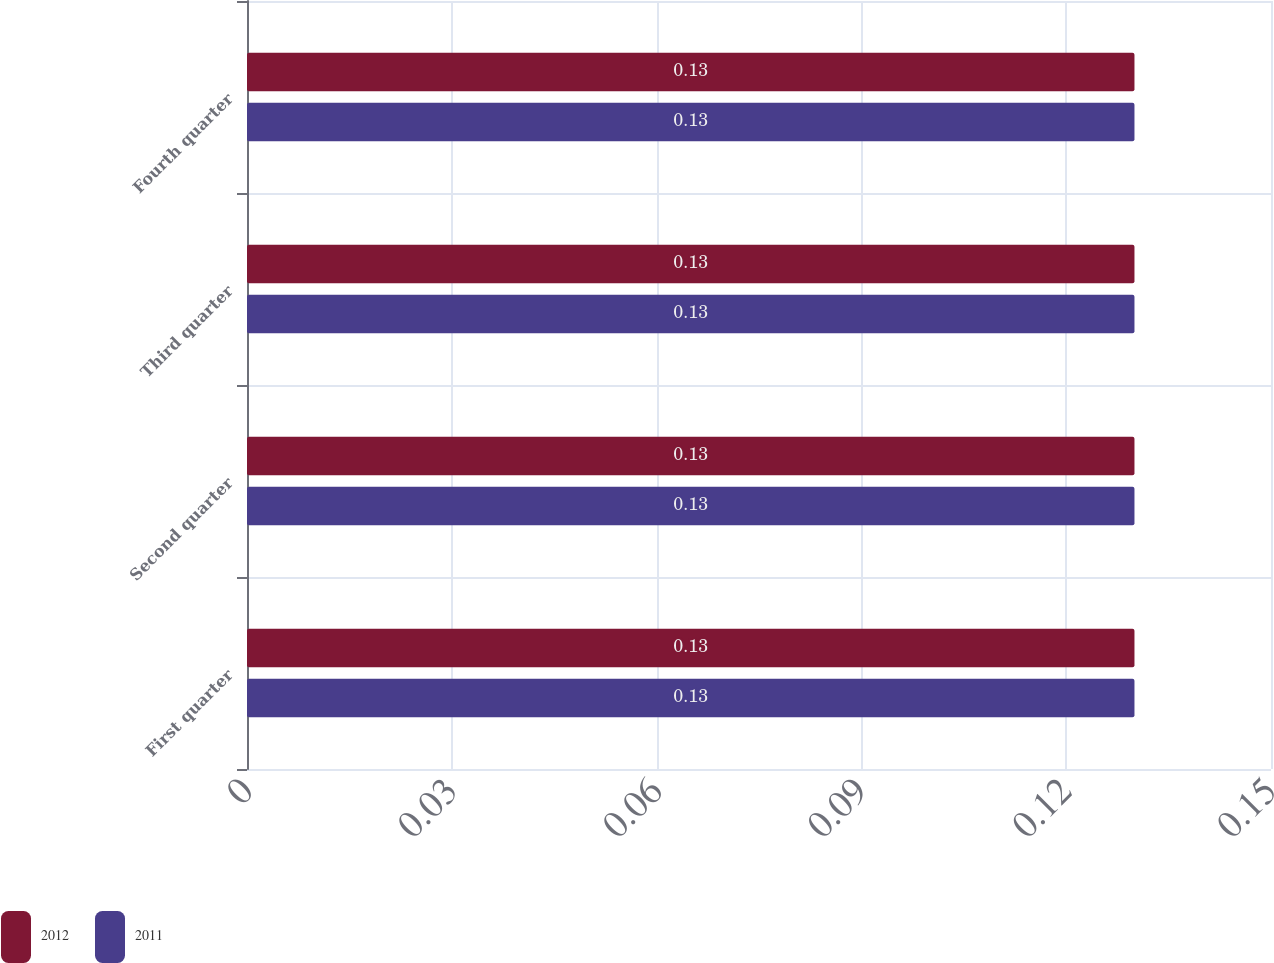Convert chart. <chart><loc_0><loc_0><loc_500><loc_500><stacked_bar_chart><ecel><fcel>First quarter<fcel>Second quarter<fcel>Third quarter<fcel>Fourth quarter<nl><fcel>2012<fcel>0.13<fcel>0.13<fcel>0.13<fcel>0.13<nl><fcel>2011<fcel>0.13<fcel>0.13<fcel>0.13<fcel>0.13<nl></chart> 